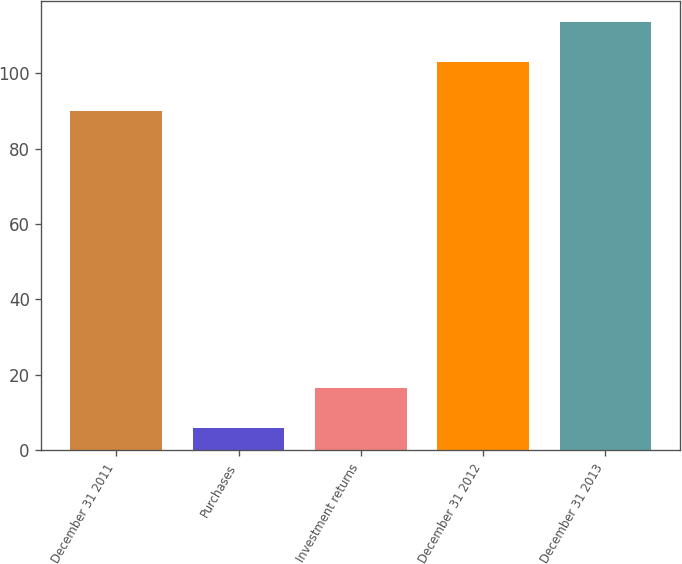Convert chart. <chart><loc_0><loc_0><loc_500><loc_500><bar_chart><fcel>December 31 2011<fcel>Purchases<fcel>Investment returns<fcel>December 31 2012<fcel>December 31 2013<nl><fcel>90<fcel>6<fcel>16.6<fcel>103<fcel>113.6<nl></chart> 